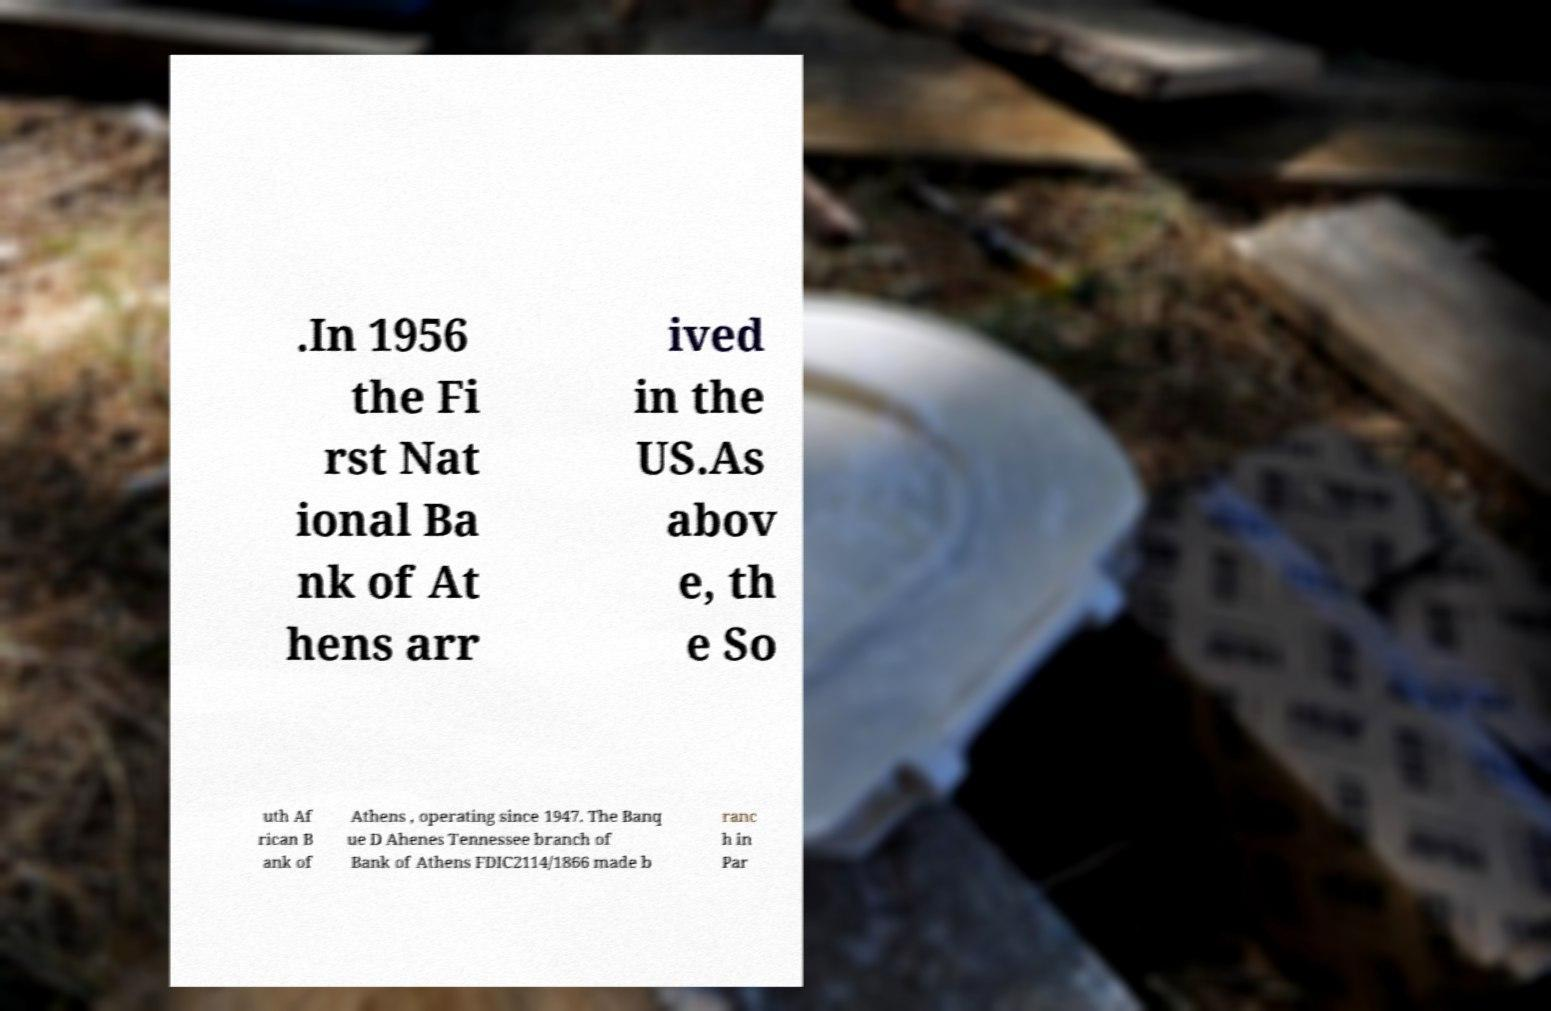Please read and relay the text visible in this image. What does it say? .In 1956 the Fi rst Nat ional Ba nk of At hens arr ived in the US.As abov e, th e So uth Af rican B ank of Athens , operating since 1947. The Banq ue D Ahenes Tennessee branch of Bank of Athens FDIC2114/1866 made b ranc h in Par 